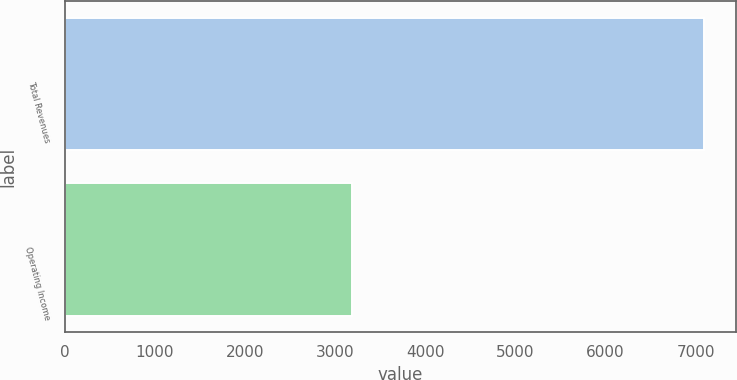<chart> <loc_0><loc_0><loc_500><loc_500><bar_chart><fcel>Total Revenues<fcel>Operating Income<nl><fcel>7091<fcel>3190<nl></chart> 